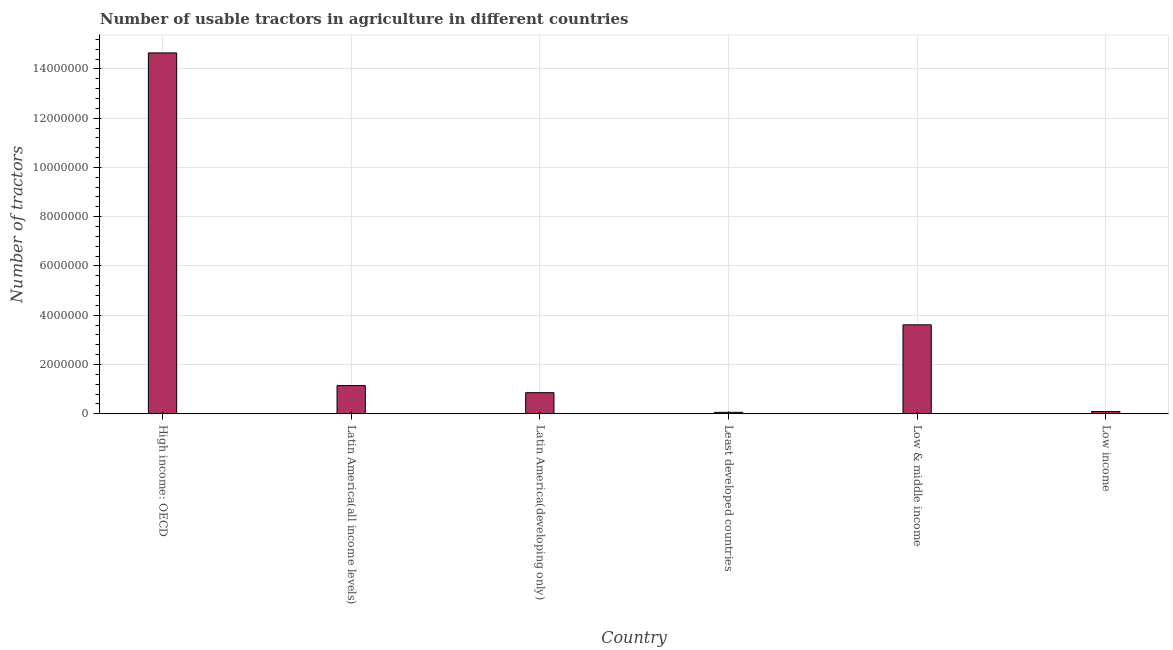Does the graph contain any zero values?
Provide a succinct answer. No. Does the graph contain grids?
Provide a short and direct response. Yes. What is the title of the graph?
Keep it short and to the point. Number of usable tractors in agriculture in different countries. What is the label or title of the Y-axis?
Give a very brief answer. Number of tractors. What is the number of tractors in Latin America(developing only)?
Your answer should be very brief. 8.54e+05. Across all countries, what is the maximum number of tractors?
Offer a very short reply. 1.46e+07. Across all countries, what is the minimum number of tractors?
Your answer should be compact. 5.73e+04. In which country was the number of tractors maximum?
Keep it short and to the point. High income: OECD. In which country was the number of tractors minimum?
Your answer should be very brief. Least developed countries. What is the sum of the number of tractors?
Your response must be concise. 2.04e+07. What is the difference between the number of tractors in Latin America(all income levels) and Low & middle income?
Offer a very short reply. -2.47e+06. What is the average number of tractors per country?
Provide a succinct answer. 3.40e+06. What is the median number of tractors?
Your response must be concise. 9.99e+05. In how many countries, is the number of tractors greater than 11200000 ?
Your answer should be very brief. 1. What is the ratio of the number of tractors in High income: OECD to that in Least developed countries?
Ensure brevity in your answer.  255.79. Is the difference between the number of tractors in Latin America(all income levels) and Least developed countries greater than the difference between any two countries?
Offer a terse response. No. What is the difference between the highest and the second highest number of tractors?
Your answer should be compact. 1.10e+07. Is the sum of the number of tractors in Latin America(developing only) and Low income greater than the maximum number of tractors across all countries?
Your response must be concise. No. What is the difference between the highest and the lowest number of tractors?
Offer a terse response. 1.46e+07. In how many countries, is the number of tractors greater than the average number of tractors taken over all countries?
Offer a terse response. 2. How many bars are there?
Keep it short and to the point. 6. How many countries are there in the graph?
Your answer should be very brief. 6. What is the difference between two consecutive major ticks on the Y-axis?
Provide a succinct answer. 2.00e+06. What is the Number of tractors in High income: OECD?
Offer a terse response. 1.46e+07. What is the Number of tractors in Latin America(all income levels)?
Make the answer very short. 1.14e+06. What is the Number of tractors in Latin America(developing only)?
Give a very brief answer. 8.54e+05. What is the Number of tractors of Least developed countries?
Provide a short and direct response. 5.73e+04. What is the Number of tractors in Low & middle income?
Keep it short and to the point. 3.61e+06. What is the Number of tractors of Low income?
Ensure brevity in your answer.  8.98e+04. What is the difference between the Number of tractors in High income: OECD and Latin America(all income levels)?
Provide a succinct answer. 1.35e+07. What is the difference between the Number of tractors in High income: OECD and Latin America(developing only)?
Ensure brevity in your answer.  1.38e+07. What is the difference between the Number of tractors in High income: OECD and Least developed countries?
Your answer should be very brief. 1.46e+07. What is the difference between the Number of tractors in High income: OECD and Low & middle income?
Your answer should be very brief. 1.10e+07. What is the difference between the Number of tractors in High income: OECD and Low income?
Your response must be concise. 1.46e+07. What is the difference between the Number of tractors in Latin America(all income levels) and Latin America(developing only)?
Your answer should be compact. 2.89e+05. What is the difference between the Number of tractors in Latin America(all income levels) and Least developed countries?
Your answer should be very brief. 1.09e+06. What is the difference between the Number of tractors in Latin America(all income levels) and Low & middle income?
Your response must be concise. -2.47e+06. What is the difference between the Number of tractors in Latin America(all income levels) and Low income?
Offer a very short reply. 1.05e+06. What is the difference between the Number of tractors in Latin America(developing only) and Least developed countries?
Provide a short and direct response. 7.97e+05. What is the difference between the Number of tractors in Latin America(developing only) and Low & middle income?
Offer a terse response. -2.76e+06. What is the difference between the Number of tractors in Latin America(developing only) and Low income?
Make the answer very short. 7.64e+05. What is the difference between the Number of tractors in Least developed countries and Low & middle income?
Your answer should be very brief. -3.55e+06. What is the difference between the Number of tractors in Least developed countries and Low income?
Give a very brief answer. -3.26e+04. What is the difference between the Number of tractors in Low & middle income and Low income?
Keep it short and to the point. 3.52e+06. What is the ratio of the Number of tractors in High income: OECD to that in Latin America(all income levels)?
Keep it short and to the point. 12.82. What is the ratio of the Number of tractors in High income: OECD to that in Latin America(developing only)?
Offer a very short reply. 17.15. What is the ratio of the Number of tractors in High income: OECD to that in Least developed countries?
Provide a succinct answer. 255.79. What is the ratio of the Number of tractors in High income: OECD to that in Low & middle income?
Make the answer very short. 4.06. What is the ratio of the Number of tractors in High income: OECD to that in Low income?
Provide a succinct answer. 163.06. What is the ratio of the Number of tractors in Latin America(all income levels) to that in Latin America(developing only)?
Your response must be concise. 1.34. What is the ratio of the Number of tractors in Latin America(all income levels) to that in Least developed countries?
Keep it short and to the point. 19.96. What is the ratio of the Number of tractors in Latin America(all income levels) to that in Low & middle income?
Offer a terse response. 0.32. What is the ratio of the Number of tractors in Latin America(all income levels) to that in Low income?
Your response must be concise. 12.72. What is the ratio of the Number of tractors in Latin America(developing only) to that in Least developed countries?
Your answer should be very brief. 14.91. What is the ratio of the Number of tractors in Latin America(developing only) to that in Low & middle income?
Make the answer very short. 0.24. What is the ratio of the Number of tractors in Latin America(developing only) to that in Low income?
Your response must be concise. 9.51. What is the ratio of the Number of tractors in Least developed countries to that in Low & middle income?
Provide a short and direct response. 0.02. What is the ratio of the Number of tractors in Least developed countries to that in Low income?
Your response must be concise. 0.64. What is the ratio of the Number of tractors in Low & middle income to that in Low income?
Offer a very short reply. 40.19. 